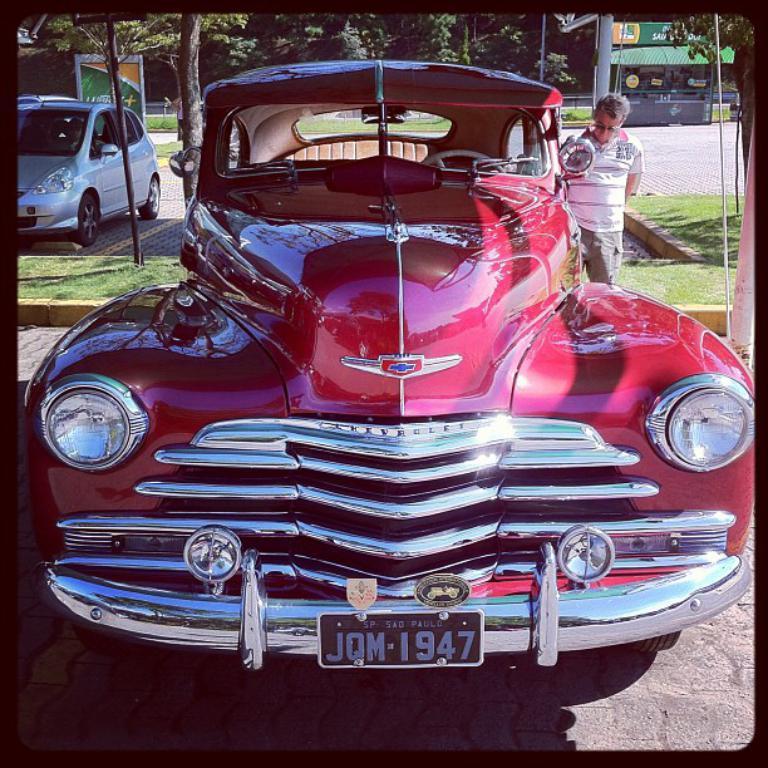How would you summarize this image in a sentence or two? In this image in the center there is one car, beside the car there is one person standing. And in the background there are buildings, trees, poles and grass pavement and at the bottom of the image there is road. 